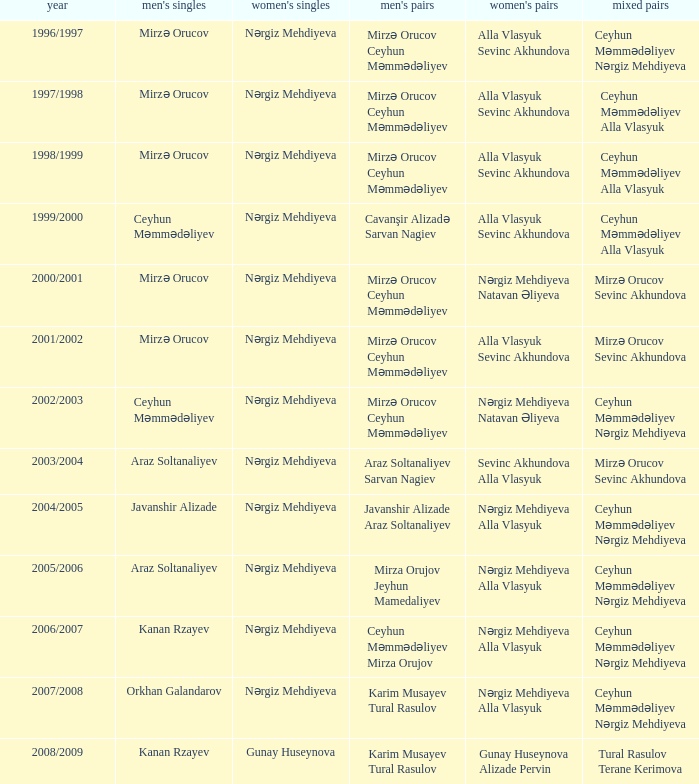Who were all womens doubles for the year 2000/2001? Nərgiz Mehdiyeva Natavan Əliyeva. 